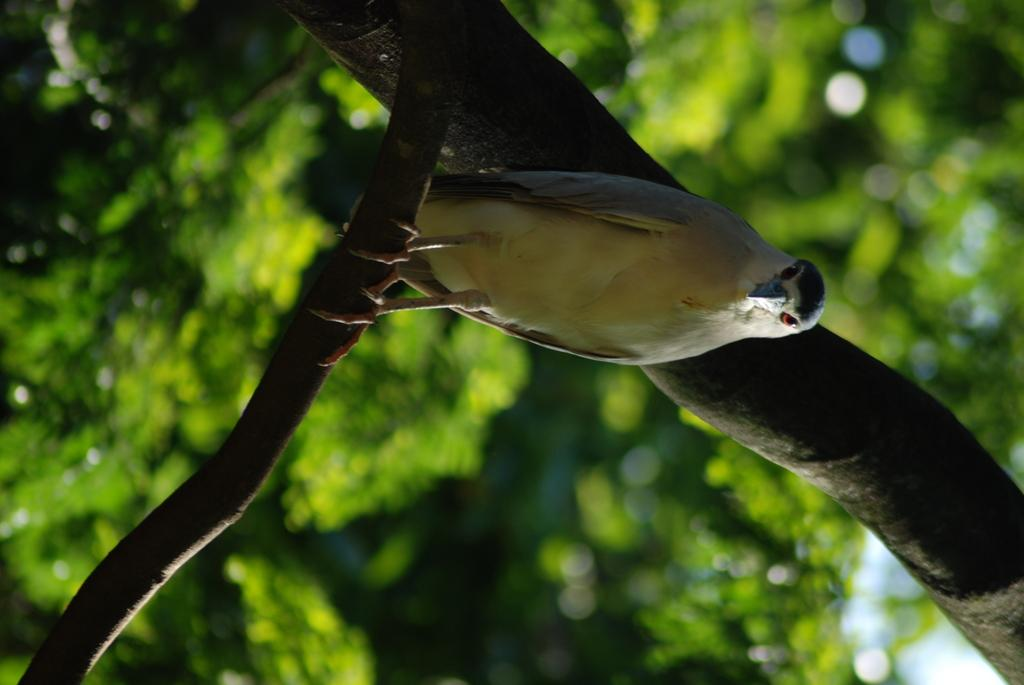What is the main subject in the foreground of the image? There is a bird in the foreground of the image. Where is the bird located? The bird is on a branch. What part of the tree can be seen in the image? There is a tree trunk visible in the image. What type of environment is depicted in the background? The background of the image consists of greenery. What is the price of the sock that the minister is wearing in the image? There is no sock or minister present in the image; it features a bird on a branch. 